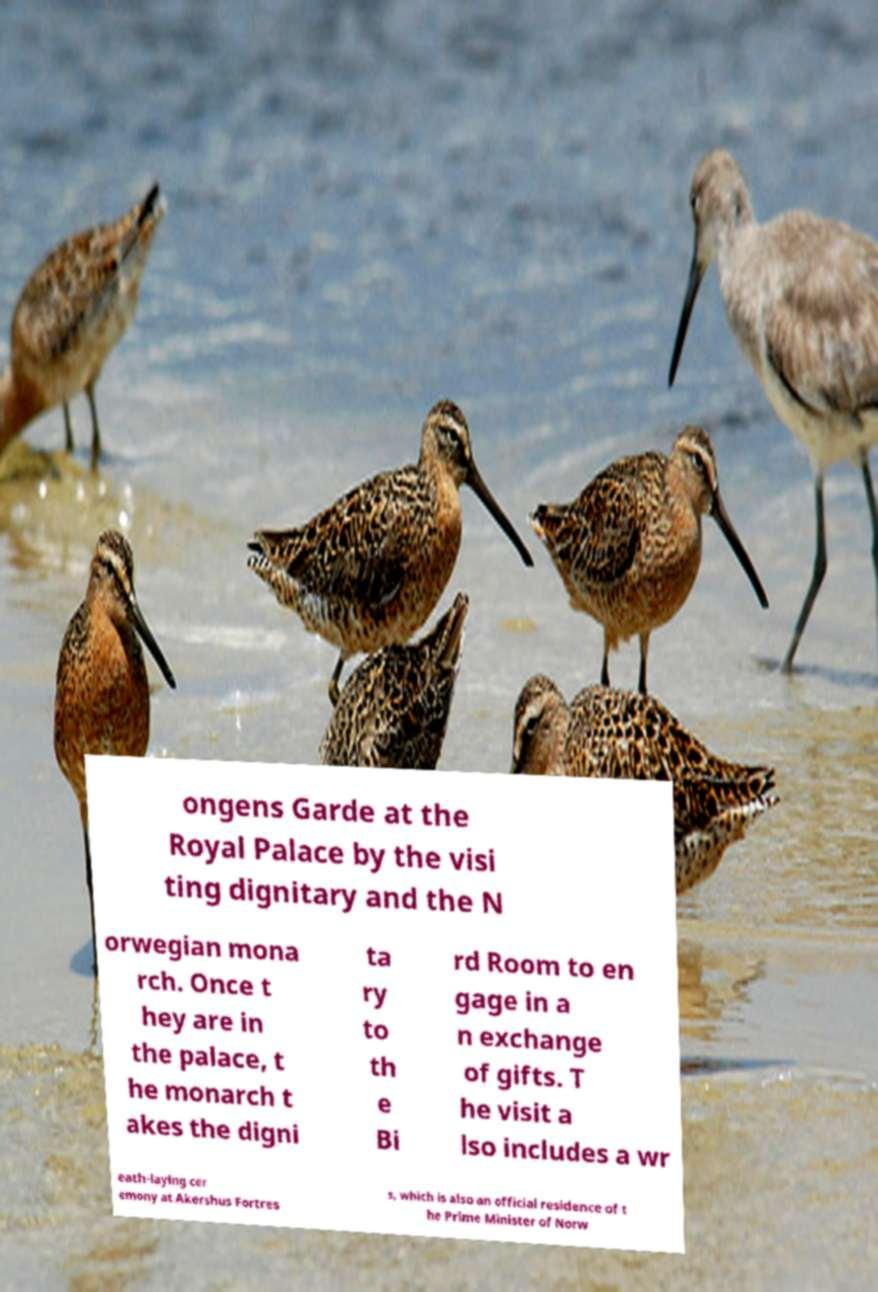Please identify and transcribe the text found in this image. ongens Garde at the Royal Palace by the visi ting dignitary and the N orwegian mona rch. Once t hey are in the palace, t he monarch t akes the digni ta ry to th e Bi rd Room to en gage in a n exchange of gifts. T he visit a lso includes a wr eath-laying cer emony at Akershus Fortres s, which is also an official residence of t he Prime Minister of Norw 